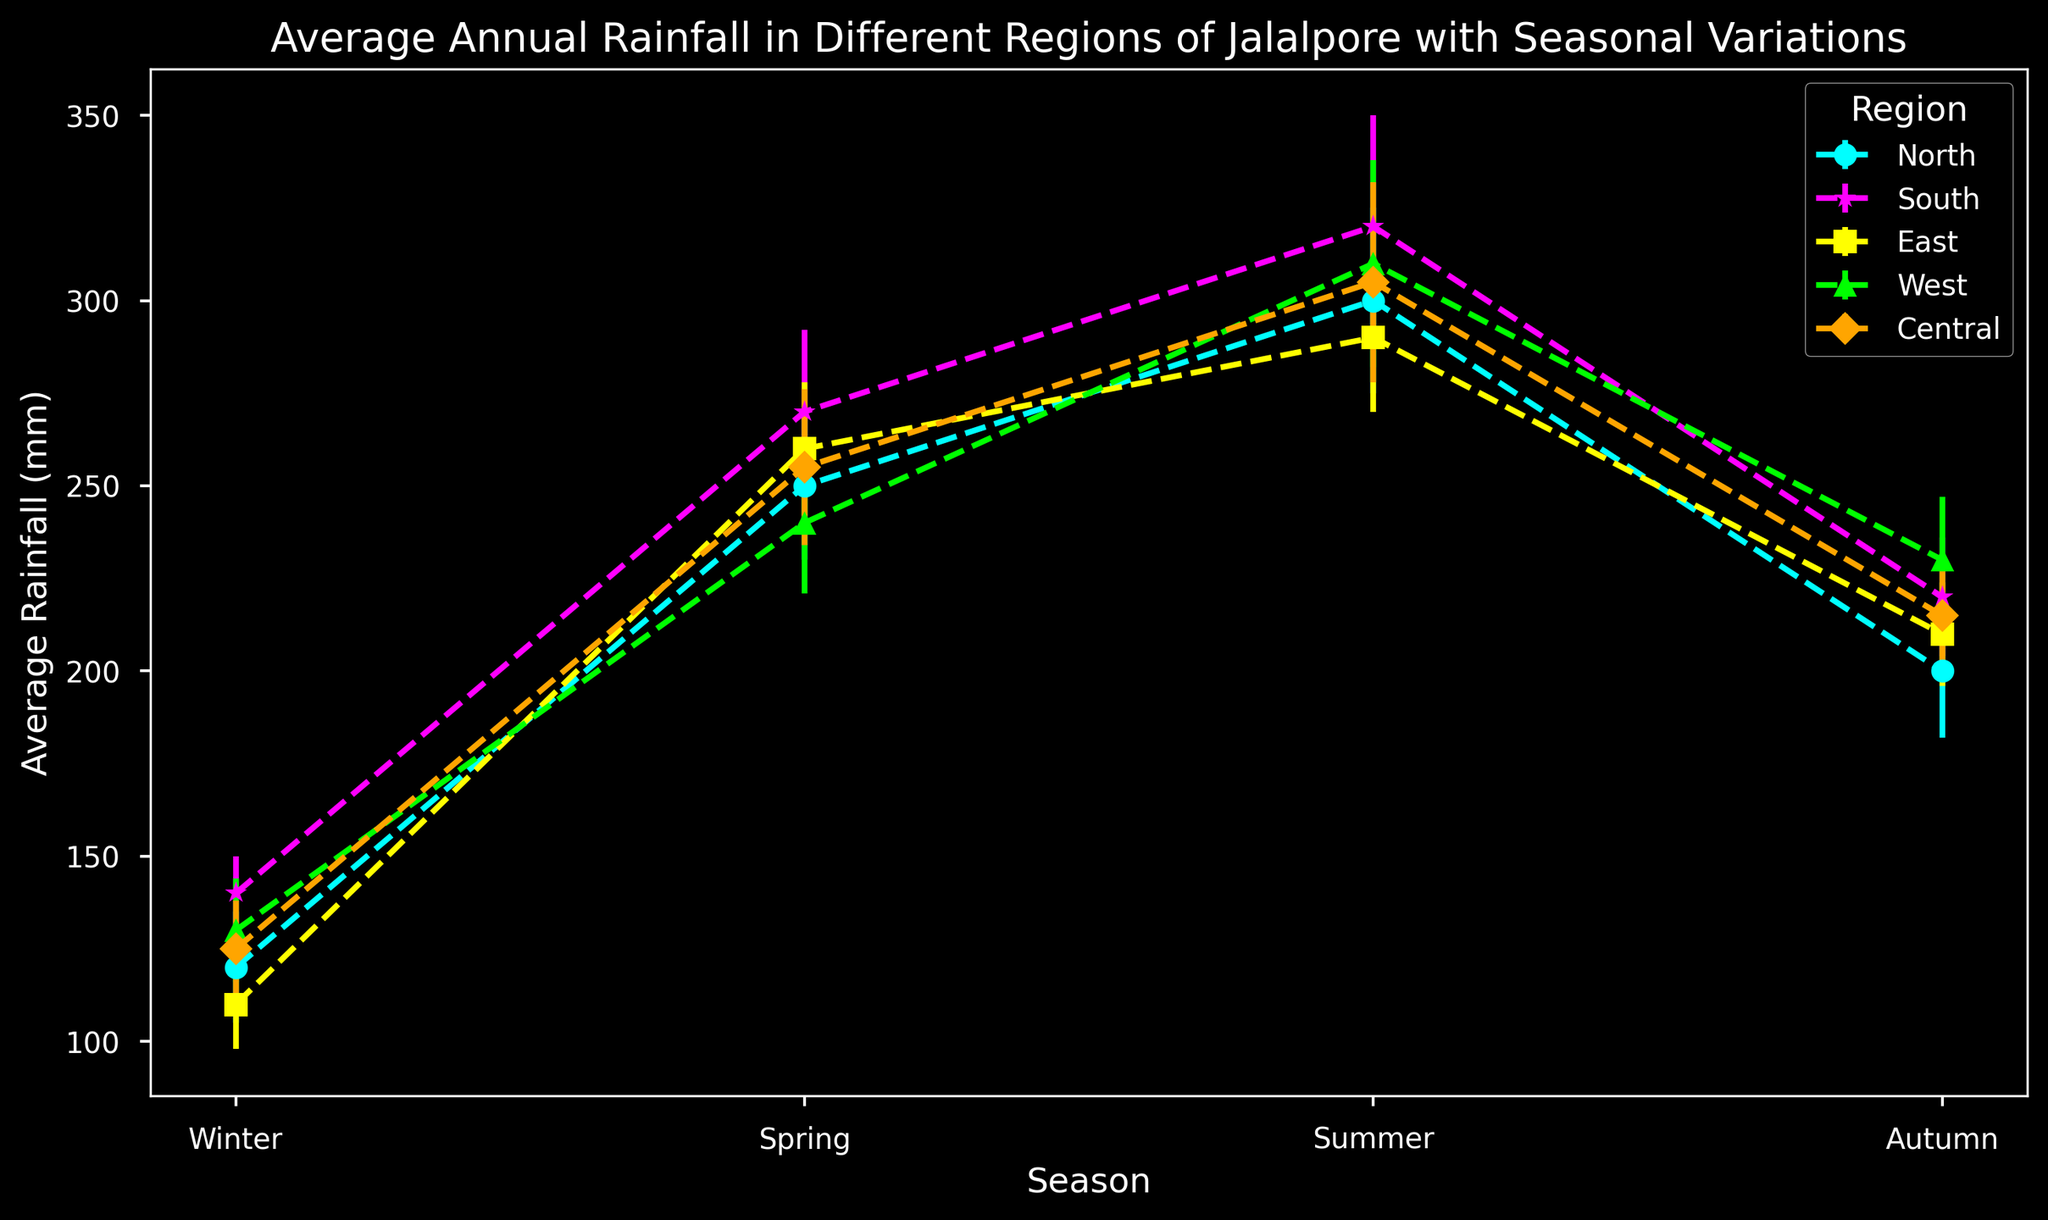What's the region with the highest average rainfall in Summer? To find the region with the highest average rainfall in Summer, look at the Summer data points and identify the highest value. The highest average rainfall in Summer is 320 mm in the South region.
Answer: South Which season has the lowest average rainfall in the East region? Look at the rainfall values for each season in the East region. The lowest average rainfall in the East region is in Winter with 110 mm.
Answer: Winter Compare the average rainfall between the North and West regions in Autumn. Which one is higher? Check the average rainfall values for the Autumn season in both North and West regions. The North region has 200 mm while the West region has 230 mm, so the West region has higher rainfall in Autumn.
Answer: West What is the total average rainfall in the Central region across all seasons? Sum the average rainfall values for all seasons in the Central region: 125 mm (Winter) + 255 mm (Spring) + 305 mm (Summer) + 215 mm (Autumn) = 900 mm.
Answer: 900 mm Which region shows the smallest error in the Winter season? Analyze the error values for Winter in all regions. The South region has the smallest error value of 10 mm in Winter.
Answer: South Is the average rainfall more variable in the South region or the East region during Summer? Compare the error values for Summer in the South and East regions. The South region has an error of 30 mm, while the East region has an error of 20 mm. Therefore, the average rainfall is more variable in the South region during Summer.
Answer: South How much more average rainfall does the West region get in Summer compared to Winter? Subtract the average rainfall in Winter from the average rainfall in Summer for the West region: 310 mm (Summer) - 130 mm (Winter) = 180 mm.
Answer: 180 mm Which seasons have the same average rainfall in the North and West regions? Compare the average rainfall values for each season in both North and West regions. Both regions have 240 mm of average rainfall in Spring.
Answer: Spring What is the difference in average rainfall between the Central and East regions in Autumn? Subtract the average rainfall value of the East region from the Central region in Autumn: 215 mm (Central) - 210 mm (East) = 5 mm.
Answer: 5 mm Across all regions, which season generally has the highest average rainfall? Look at the average rainfall data for all regions across all seasons and find the season with consistently high values. Summer has the highest average rainfall across most regions.
Answer: Summer 